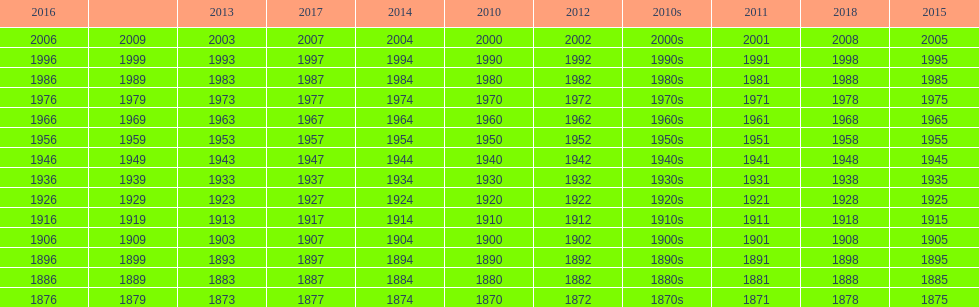What is the earliest year that a film was released? 1870. Could you parse the entire table as a dict? {'header': ['2016', '', '2013', '2017', '2014', '2010', '2012', '2010s', '2011', '2018', '2015'], 'rows': [['2006', '2009', '2003', '2007', '2004', '2000', '2002', '2000s', '2001', '2008', '2005'], ['1996', '1999', '1993', '1997', '1994', '1990', '1992', '1990s', '1991', '1998', '1995'], ['1986', '1989', '1983', '1987', '1984', '1980', '1982', '1980s', '1981', '1988', '1985'], ['1976', '1979', '1973', '1977', '1974', '1970', '1972', '1970s', '1971', '1978', '1975'], ['1966', '1969', '1963', '1967', '1964', '1960', '1962', '1960s', '1961', '1968', '1965'], ['1956', '1959', '1953', '1957', '1954', '1950', '1952', '1950s', '1951', '1958', '1955'], ['1946', '1949', '1943', '1947', '1944', '1940', '1942', '1940s', '1941', '1948', '1945'], ['1936', '1939', '1933', '1937', '1934', '1930', '1932', '1930s', '1931', '1938', '1935'], ['1926', '1929', '1923', '1927', '1924', '1920', '1922', '1920s', '1921', '1928', '1925'], ['1916', '1919', '1913', '1917', '1914', '1910', '1912', '1910s', '1911', '1918', '1915'], ['1906', '1909', '1903', '1907', '1904', '1900', '1902', '1900s', '1901', '1908', '1905'], ['1896', '1899', '1893', '1897', '1894', '1890', '1892', '1890s', '1891', '1898', '1895'], ['1886', '1889', '1883', '1887', '1884', '1880', '1882', '1880s', '1881', '1888', '1885'], ['1876', '1879', '1873', '1877', '1874', '1870', '1872', '1870s', '1871', '1878', '1875']]} 